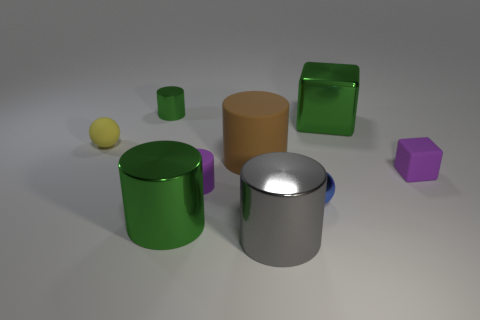Do the tiny blue thing and the big brown rubber thing have the same shape?
Ensure brevity in your answer.  No. What is the cylinder that is to the left of the purple rubber cylinder and in front of the purple rubber block made of?
Keep it short and to the point. Metal. How many purple rubber things have the same shape as the blue metal object?
Keep it short and to the point. 0. There is a green cylinder that is right of the shiny cylinder to the left of the green shiny object in front of the brown cylinder; what is its size?
Make the answer very short. Large. Is the number of rubber cylinders that are to the left of the big matte object greater than the number of yellow rubber objects?
Your response must be concise. No. Is there a metallic thing?
Provide a succinct answer. Yes. How many purple rubber cylinders are the same size as the gray thing?
Your answer should be compact. 0. Are there more blue metallic objects in front of the gray cylinder than small blocks to the left of the tiny blue thing?
Give a very brief answer. No. There is a yellow thing that is the same size as the blue metal ball; what is its material?
Offer a terse response. Rubber. What is the shape of the brown object?
Offer a terse response. Cylinder. 